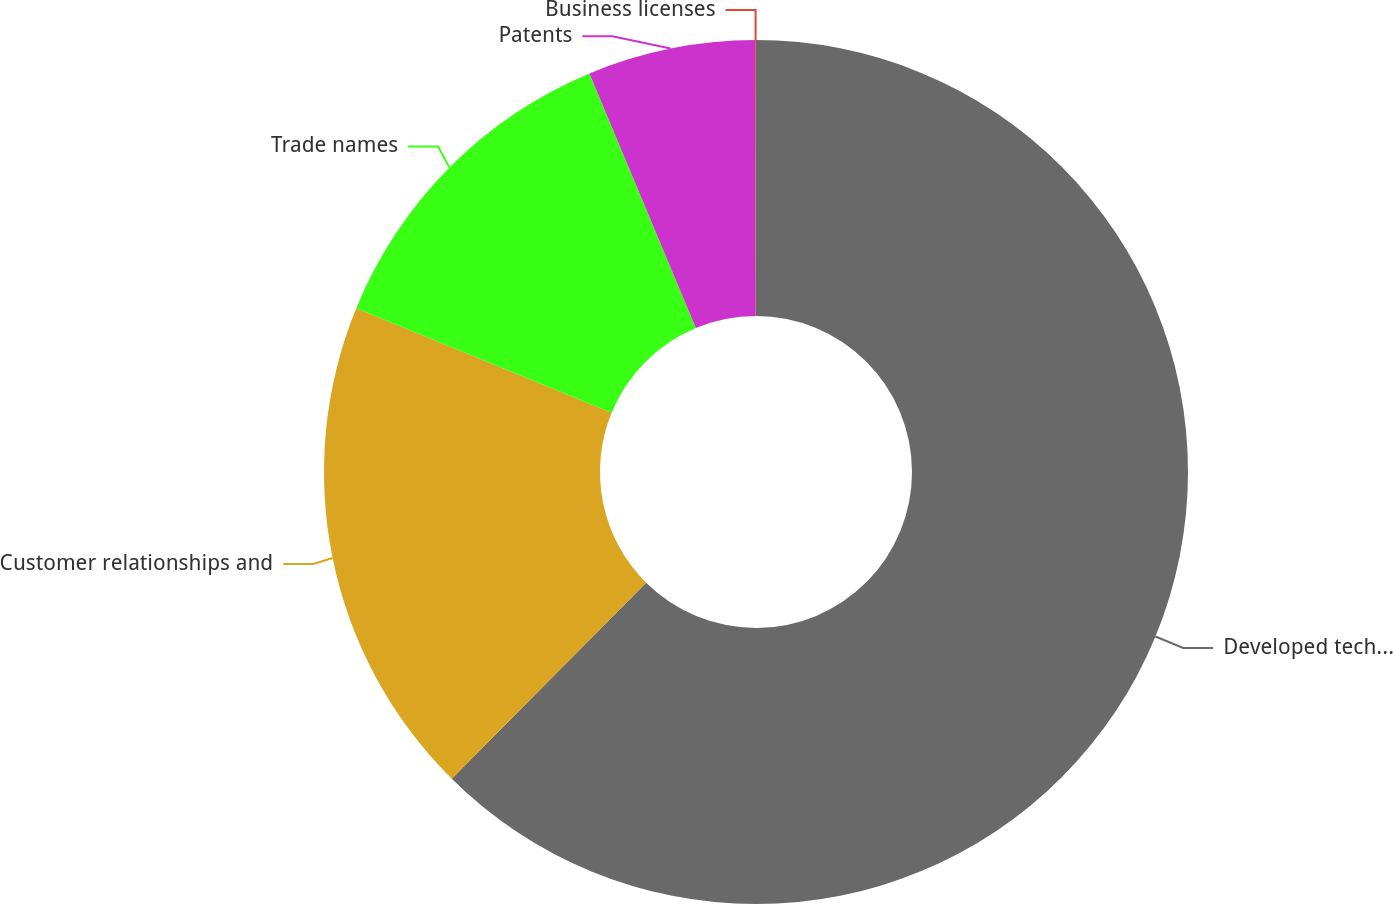Convert chart. <chart><loc_0><loc_0><loc_500><loc_500><pie_chart><fcel>Developed technology<fcel>Customer relationships and<fcel>Trade names<fcel>Patents<fcel>Business licenses<nl><fcel>62.43%<fcel>18.75%<fcel>12.51%<fcel>6.27%<fcel>0.03%<nl></chart> 